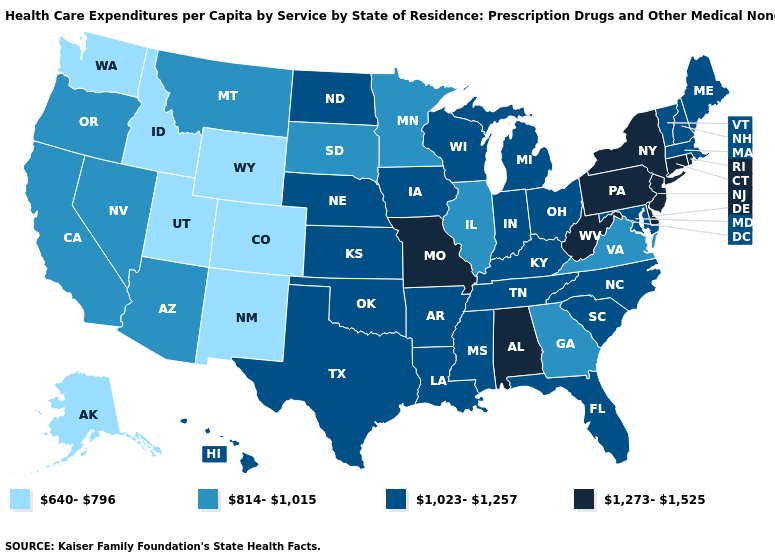Is the legend a continuous bar?
Be succinct. No. Which states hav the highest value in the West?
Be succinct. Hawaii. What is the lowest value in the USA?
Give a very brief answer. 640-796. Does Ohio have the highest value in the MidWest?
Short answer required. No. What is the lowest value in the USA?
Concise answer only. 640-796. Which states have the highest value in the USA?
Short answer required. Alabama, Connecticut, Delaware, Missouri, New Jersey, New York, Pennsylvania, Rhode Island, West Virginia. Does Indiana have the same value as Ohio?
Keep it brief. Yes. How many symbols are there in the legend?
Short answer required. 4. What is the value of Oklahoma?
Give a very brief answer. 1,023-1,257. Name the states that have a value in the range 1,273-1,525?
Quick response, please. Alabama, Connecticut, Delaware, Missouri, New Jersey, New York, Pennsylvania, Rhode Island, West Virginia. What is the highest value in the USA?
Concise answer only. 1,273-1,525. Name the states that have a value in the range 814-1,015?
Keep it brief. Arizona, California, Georgia, Illinois, Minnesota, Montana, Nevada, Oregon, South Dakota, Virginia. What is the value of Louisiana?
Quick response, please. 1,023-1,257. What is the value of Michigan?
Keep it brief. 1,023-1,257. Does Florida have the lowest value in the USA?
Concise answer only. No. 